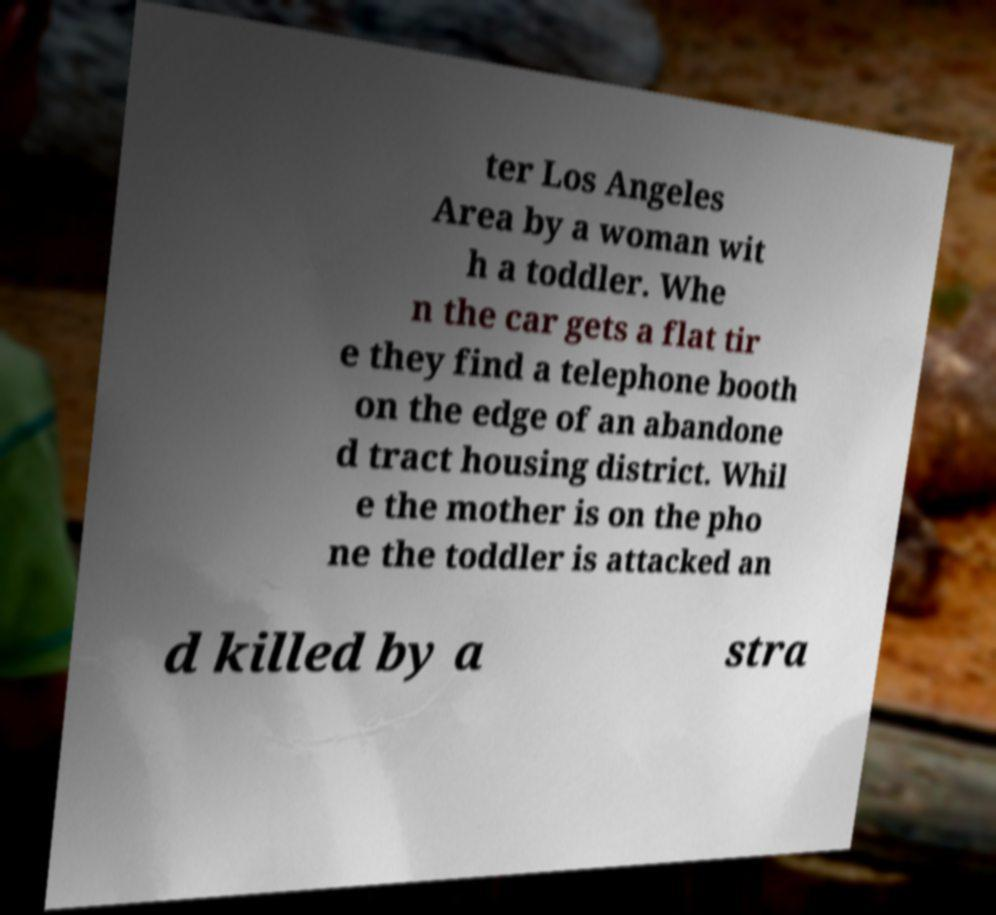Can you read and provide the text displayed in the image?This photo seems to have some interesting text. Can you extract and type it out for me? ter Los Angeles Area by a woman wit h a toddler. Whe n the car gets a flat tir e they find a telephone booth on the edge of an abandone d tract housing district. Whil e the mother is on the pho ne the toddler is attacked an d killed by a stra 